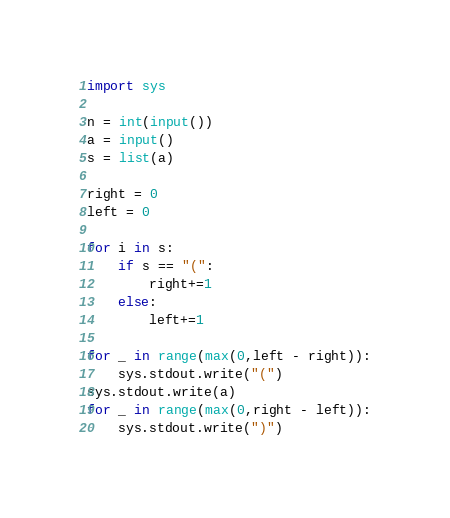<code> <loc_0><loc_0><loc_500><loc_500><_Python_>import sys

n = int(input())
a = input()
s = list(a)

right = 0
left = 0

for i in s:
    if s == "(":
        right+=1
    else:
        left+=1

for _ in range(max(0,left - right)):
    sys.stdout.write("(")
sys.stdout.write(a)
for _ in range(max(0,right - left)):
    sys.stdout.write(")")</code> 